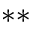<formula> <loc_0><loc_0><loc_500><loc_500>^ { * * }</formula> 